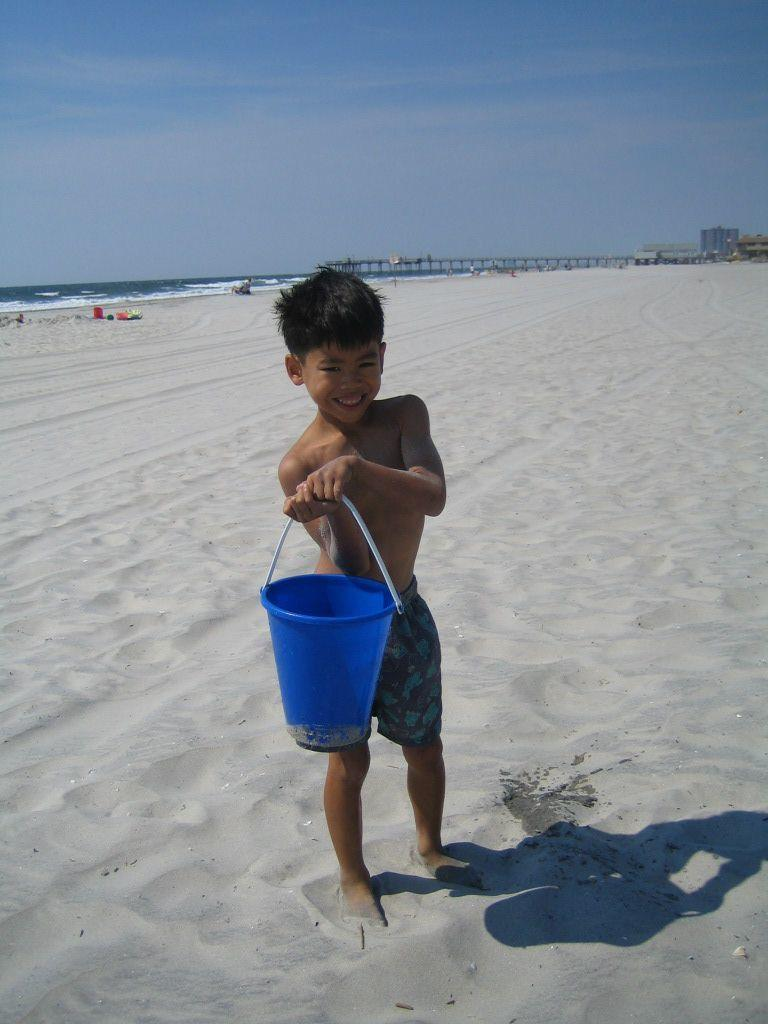What is the main subject of the image? There is a child in the image. What is the child holding in the image? The child is holding a bucket. Where is the child standing in the image? The child is standing on the sand. What type of structure can be seen in the image? There is a bridge in the image. What type of buildings are visible in the image? There are buildings in the image. What natural feature is present in the image? There is a sea in the image. What can be found on the sand in the image? There are objects in the sand. What is visible in the sky in the image? The sky is visible in the image. What type of garden can be seen in the image? There is no garden present in the image. What is the child's interest in the copper objects in the image? There are no copper objects present in the image, and therefore no interest in them can be observed. 